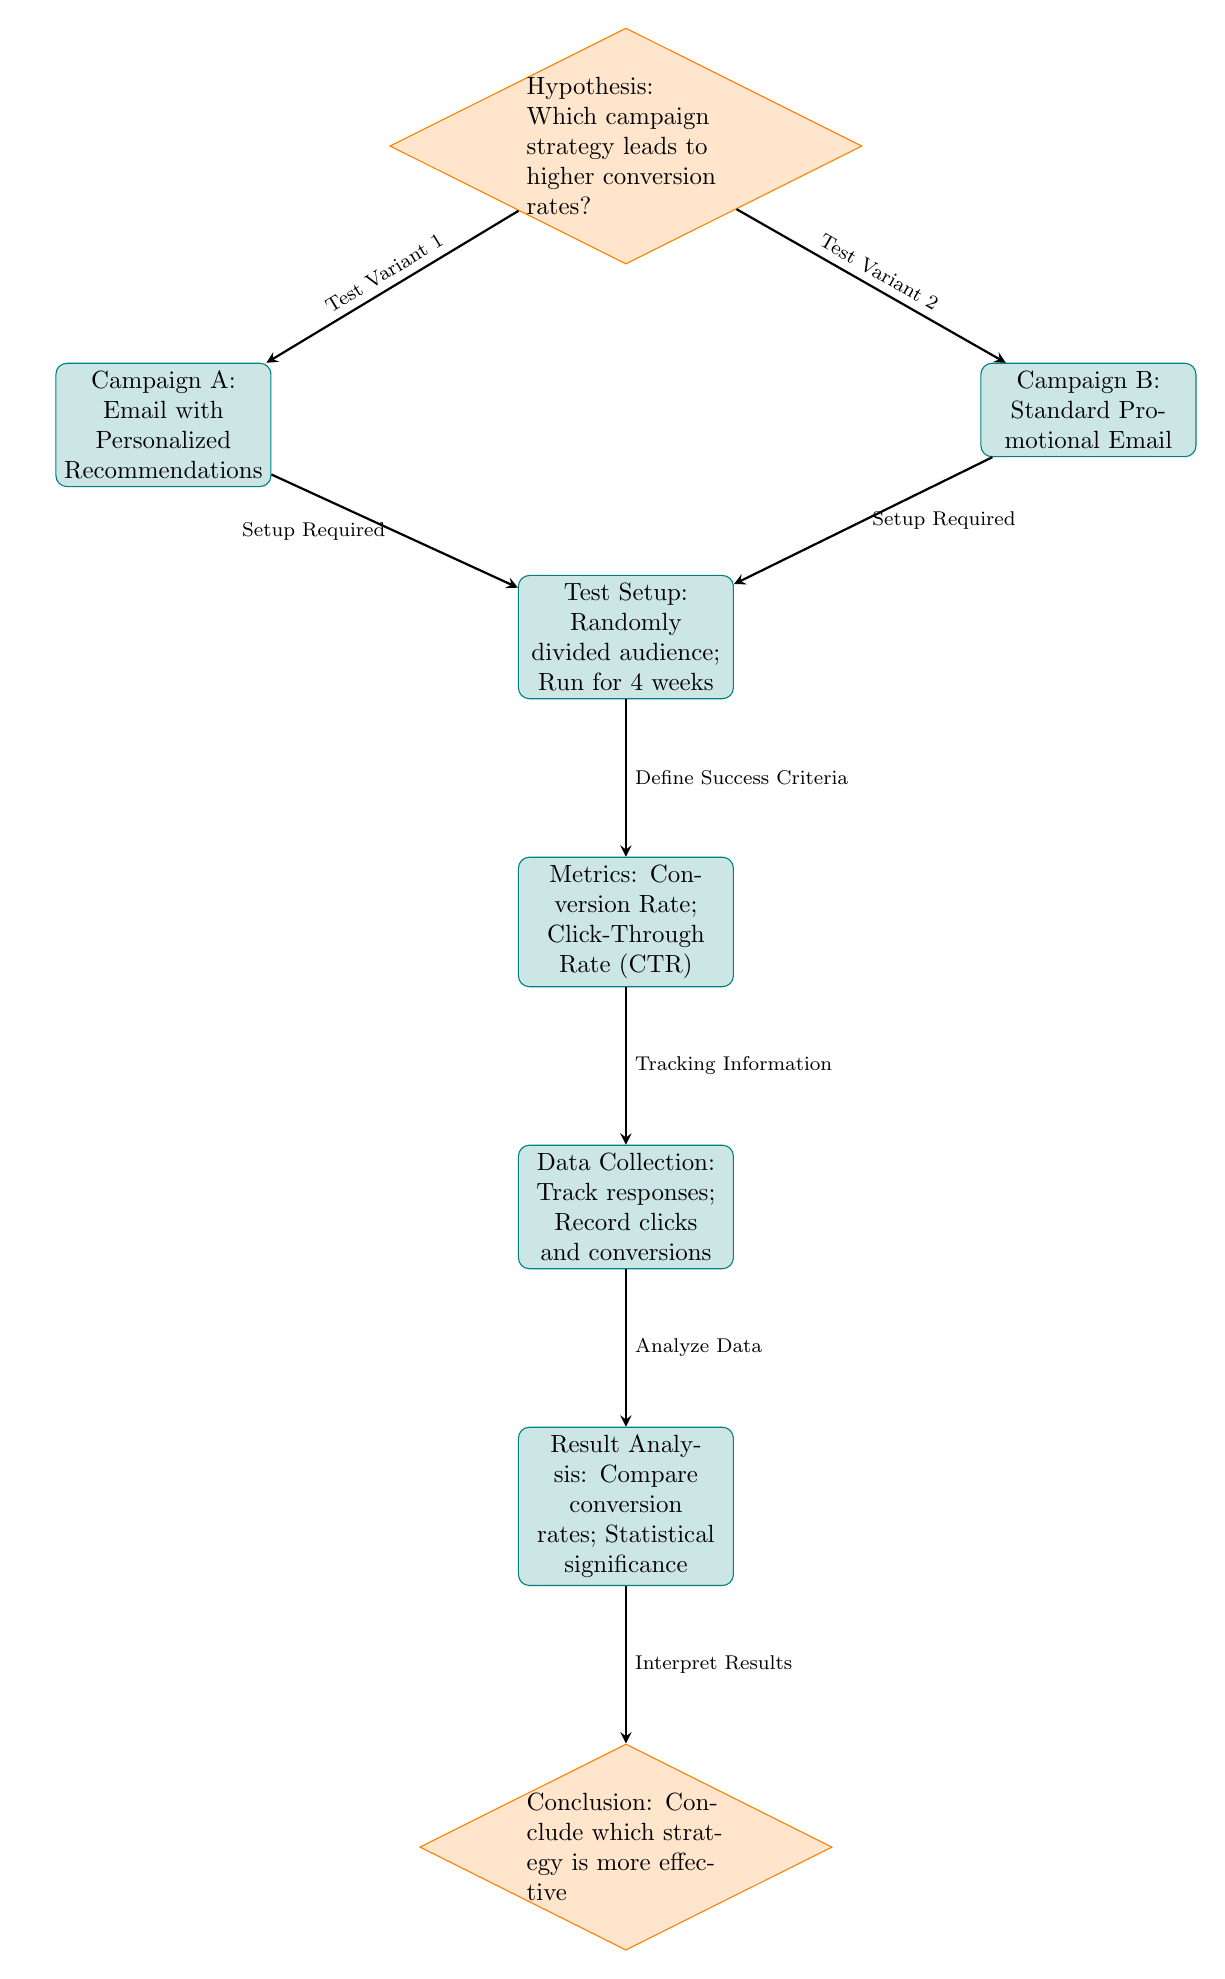What is the hypothesis being evaluated in this framework? The first node in the diagram states the hypothesis: "Which campaign strategy leads to higher conversion rates?". This clearly defines the focus of the A/B testing framework.
Answer: Which campaign strategy leads to higher conversion rates? How many campaigns are compared in this diagram? There are two campaigns mentioned: Campaign A and Campaign B. They are represented in the left and right paths stemming from the hypothesis node, indicating a direct comparison.
Answer: 2 What is the test setup duration stated in the diagram? The test setup node specifies that the audience is randomly divided and the test runs for "4 weeks", highlighting the time frame for the experiment.
Answer: 4 weeks What metrics are used for evaluation in this framework? The metrics node lists "Conversion Rate" and "Click-Through Rate (CTR)" as measures for evaluating the success of the campaigns, indicating what data will be analyzed.
Answer: Conversion Rate; Click-Through Rate (CTR) What is the final conclusion step in this framework? The conclusion node states, "Conclude which strategy is more effective", indicating that the final step of the analysis is to reach a decision based on the results.
Answer: Conclude which strategy is more effective What node follows the data collection step? The data collection node leads to the analysis node according to the flow of the diagram, indicating that data must be analyzed after it has been collected.
Answer: Result Analysis Which node represents the decision-making step in the process? The final decision-making step is represented by the conclusion node, which assesses the effectiveness of the different strategies based on the analysis.
Answer: Conclusion Which campaign uses personalized recommendations? Campaign A is explicitly labeled as "Email with Personalized Recommendations", distinguishing it from Campaign B.
Answer: Campaign A What step immediately comes after defining the success criteria? The metrics node follows the test setup, indicating that after setting up the test, the next step is to define how success will be measured through various metrics.
Answer: Metrics: Conversion Rate; Click-Through Rate (CTR) 